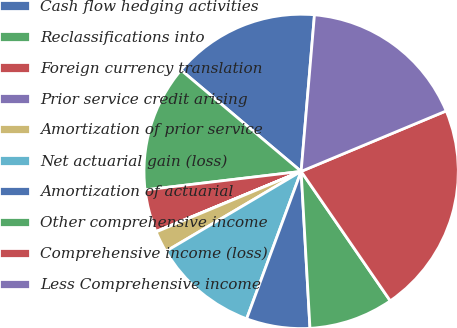Convert chart to OTSL. <chart><loc_0><loc_0><loc_500><loc_500><pie_chart><fcel>Cash flow hedging activities<fcel>Reclassifications into<fcel>Foreign currency translation<fcel>Prior service credit arising<fcel>Amortization of prior service<fcel>Net actuarial gain (loss)<fcel>Amortization of actuarial<fcel>Other comprehensive income<fcel>Comprehensive income (loss)<fcel>Less Comprehensive income<nl><fcel>15.2%<fcel>13.03%<fcel>4.37%<fcel>0.04%<fcel>2.2%<fcel>10.87%<fcel>6.53%<fcel>8.7%<fcel>21.69%<fcel>17.36%<nl></chart> 